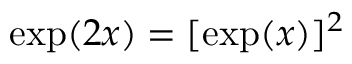<formula> <loc_0><loc_0><loc_500><loc_500>\exp ( 2 x ) = [ \exp ( x ) ] ^ { 2 }</formula> 